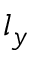Convert formula to latex. <formula><loc_0><loc_0><loc_500><loc_500>l _ { y }</formula> 